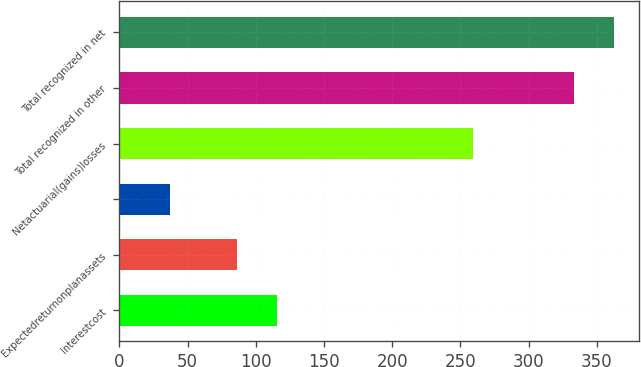Convert chart. <chart><loc_0><loc_0><loc_500><loc_500><bar_chart><fcel>Interestcost<fcel>Expectedreturnonplanassets<fcel>Unnamed: 2<fcel>Netactuarial(gains)losses<fcel>Total recognized in other<fcel>Total recognized in net<nl><fcel>115.6<fcel>86<fcel>37<fcel>259<fcel>333<fcel>362.6<nl></chart> 